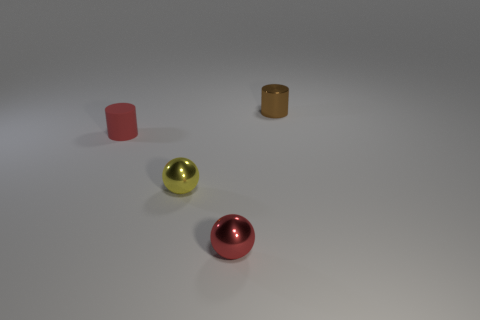Add 2 tiny red matte cylinders. How many objects exist? 6 Subtract all matte cylinders. Subtract all big red shiny objects. How many objects are left? 3 Add 4 red matte cylinders. How many red matte cylinders are left? 5 Add 4 red metallic balls. How many red metallic balls exist? 5 Subtract 0 red cubes. How many objects are left? 4 